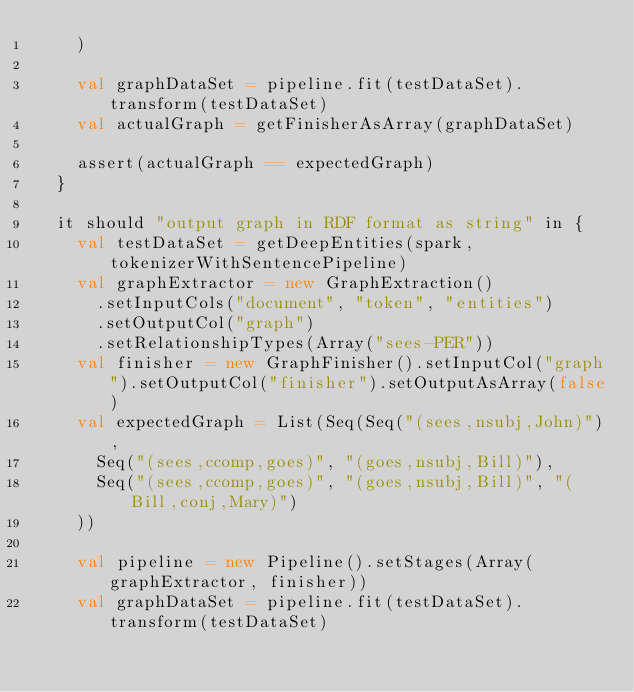Convert code to text. <code><loc_0><loc_0><loc_500><loc_500><_Scala_>    )

    val graphDataSet = pipeline.fit(testDataSet).transform(testDataSet)
    val actualGraph = getFinisherAsArray(graphDataSet)

    assert(actualGraph == expectedGraph)
  }

  it should "output graph in RDF format as string" in {
    val testDataSet = getDeepEntities(spark, tokenizerWithSentencePipeline)
    val graphExtractor = new GraphExtraction()
      .setInputCols("document", "token", "entities")
      .setOutputCol("graph")
      .setRelationshipTypes(Array("sees-PER"))
    val finisher = new GraphFinisher().setInputCol("graph").setOutputCol("finisher").setOutputAsArray(false)
    val expectedGraph = List(Seq(Seq("(sees,nsubj,John)"),
      Seq("(sees,ccomp,goes)", "(goes,nsubj,Bill)"),
      Seq("(sees,ccomp,goes)", "(goes,nsubj,Bill)", "(Bill,conj,Mary)")
    ))

    val pipeline = new Pipeline().setStages(Array(graphExtractor, finisher))
    val graphDataSet = pipeline.fit(testDataSet).transform(testDataSet)
</code> 